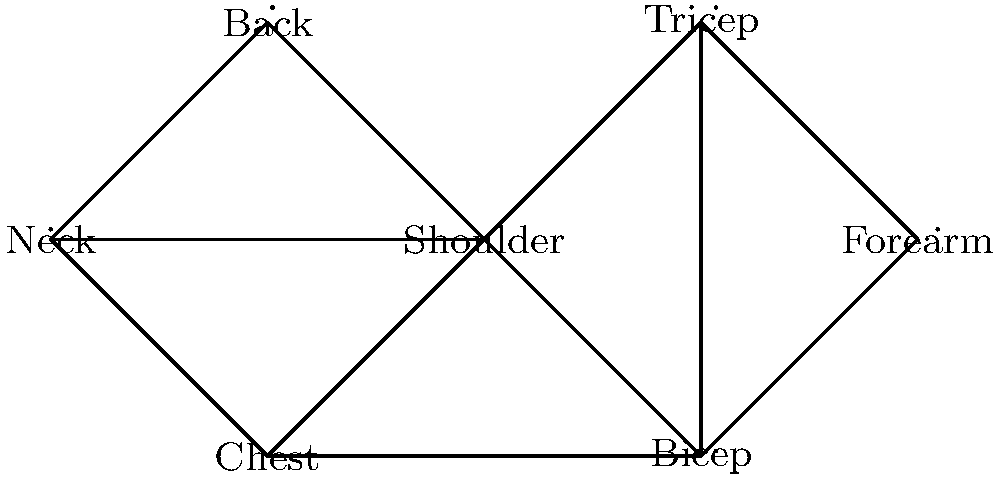In the given node-edge diagram representing muscle group connections in the upper body, which muscle group has the highest degree (most connections to other muscle groups), and how many connections does it have? To answer this question, we need to count the number of connections (edges) for each muscle group (node) in the diagram. Let's go through this step-by-step:

1. Neck: Connected to Chest, Shoulder, and Back. Degree = 3
2. Chest: Connected to Neck, Shoulder, and Bicep. Degree = 3
3. Shoulder: Connected to Neck, Chest, Back, Bicep, and Tricep. Degree = 5
4. Back: Connected to Neck and Shoulder. Degree = 2
5. Bicep: Connected to Chest, Shoulder, Forearm, and Tricep. Degree = 4
6. Forearm: Connected to Bicep and Tricep. Degree = 2
7. Tricep: Connected to Shoulder, Bicep, and Forearm. Degree = 3

After counting the connections for each muscle group, we can see that the Shoulder has the highest degree with 5 connections.
Answer: Shoulder, 5 connections 